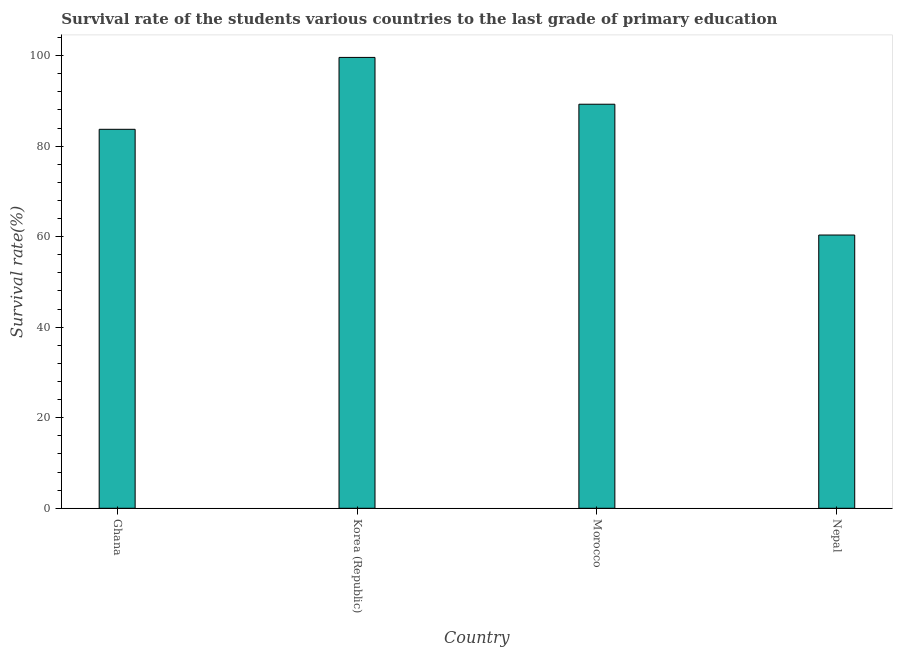Does the graph contain grids?
Your answer should be compact. No. What is the title of the graph?
Offer a very short reply. Survival rate of the students various countries to the last grade of primary education. What is the label or title of the X-axis?
Keep it short and to the point. Country. What is the label or title of the Y-axis?
Give a very brief answer. Survival rate(%). What is the survival rate in primary education in Ghana?
Keep it short and to the point. 83.71. Across all countries, what is the maximum survival rate in primary education?
Make the answer very short. 99.59. Across all countries, what is the minimum survival rate in primary education?
Provide a succinct answer. 60.36. In which country was the survival rate in primary education minimum?
Your answer should be compact. Nepal. What is the sum of the survival rate in primary education?
Your answer should be very brief. 332.92. What is the difference between the survival rate in primary education in Morocco and Nepal?
Your answer should be very brief. 28.89. What is the average survival rate in primary education per country?
Your answer should be very brief. 83.23. What is the median survival rate in primary education?
Your response must be concise. 86.48. In how many countries, is the survival rate in primary education greater than 48 %?
Make the answer very short. 4. What is the ratio of the survival rate in primary education in Ghana to that in Korea (Republic)?
Provide a succinct answer. 0.84. Is the survival rate in primary education in Korea (Republic) less than that in Morocco?
Your answer should be compact. No. What is the difference between the highest and the second highest survival rate in primary education?
Make the answer very short. 10.34. What is the difference between the highest and the lowest survival rate in primary education?
Provide a succinct answer. 39.23. In how many countries, is the survival rate in primary education greater than the average survival rate in primary education taken over all countries?
Make the answer very short. 3. How many bars are there?
Provide a short and direct response. 4. How many countries are there in the graph?
Offer a terse response. 4. What is the Survival rate(%) in Ghana?
Offer a very short reply. 83.71. What is the Survival rate(%) in Korea (Republic)?
Your response must be concise. 99.59. What is the Survival rate(%) in Morocco?
Keep it short and to the point. 89.25. What is the Survival rate(%) in Nepal?
Provide a short and direct response. 60.36. What is the difference between the Survival rate(%) in Ghana and Korea (Republic)?
Ensure brevity in your answer.  -15.88. What is the difference between the Survival rate(%) in Ghana and Morocco?
Provide a succinct answer. -5.54. What is the difference between the Survival rate(%) in Ghana and Nepal?
Make the answer very short. 23.35. What is the difference between the Survival rate(%) in Korea (Republic) and Morocco?
Your answer should be compact. 10.34. What is the difference between the Survival rate(%) in Korea (Republic) and Nepal?
Provide a short and direct response. 39.23. What is the difference between the Survival rate(%) in Morocco and Nepal?
Your response must be concise. 28.89. What is the ratio of the Survival rate(%) in Ghana to that in Korea (Republic)?
Provide a succinct answer. 0.84. What is the ratio of the Survival rate(%) in Ghana to that in Morocco?
Your answer should be compact. 0.94. What is the ratio of the Survival rate(%) in Ghana to that in Nepal?
Provide a succinct answer. 1.39. What is the ratio of the Survival rate(%) in Korea (Republic) to that in Morocco?
Your response must be concise. 1.12. What is the ratio of the Survival rate(%) in Korea (Republic) to that in Nepal?
Keep it short and to the point. 1.65. What is the ratio of the Survival rate(%) in Morocco to that in Nepal?
Ensure brevity in your answer.  1.48. 